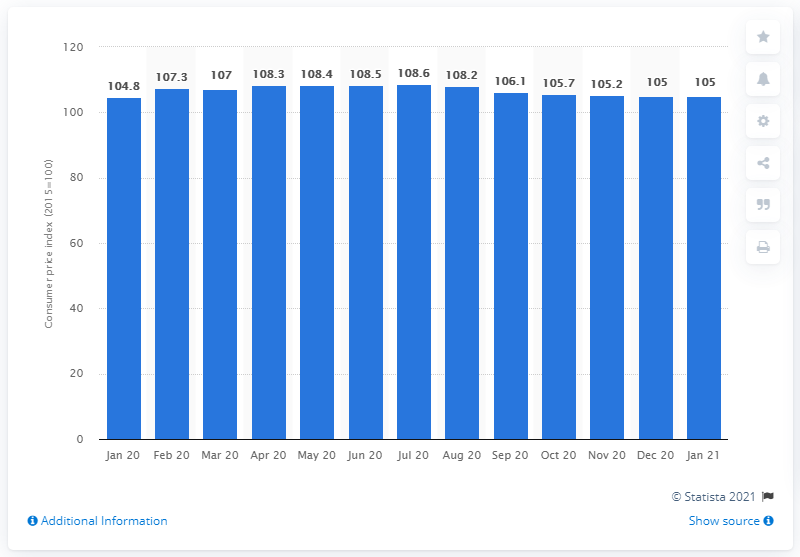Highlight a few significant elements in this photo. In June 2020, the Consumer Price Index (CPI) for vegetables in Denmark was 108.5. 